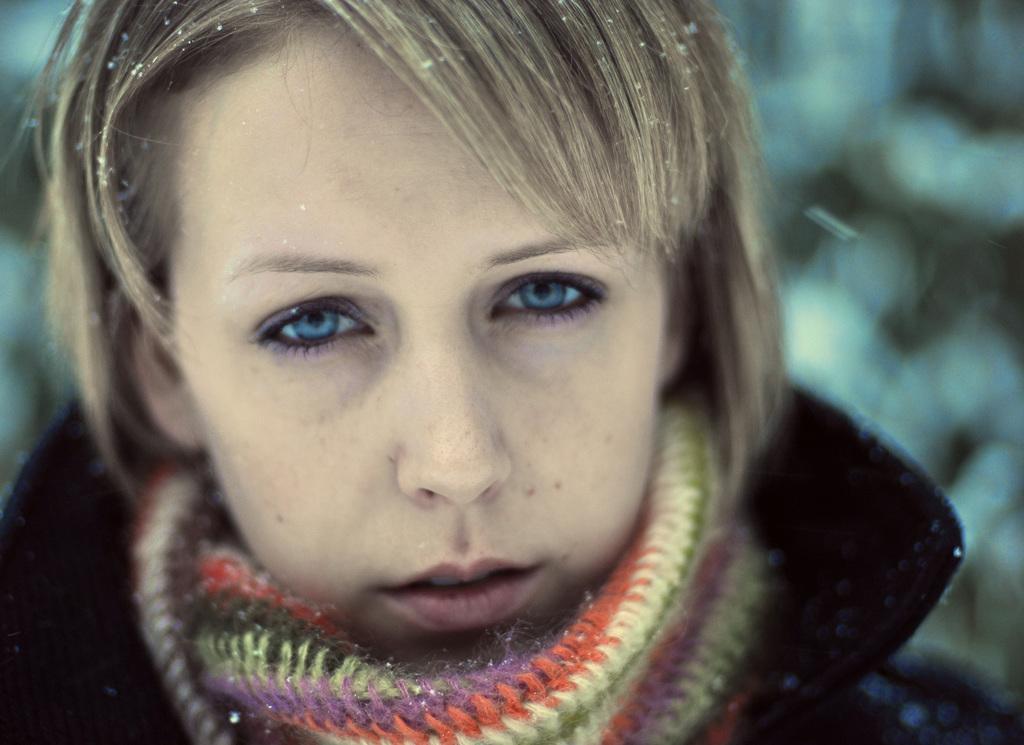Could you give a brief overview of what you see in this image? In this image we can see a lady wearing a jacket and a scarf. The background of the image is not clear. 